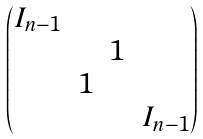<formula> <loc_0><loc_0><loc_500><loc_500>\begin{pmatrix} I _ { n - 1 } & & & \\ & & 1 & \\ & 1 & & \\ & & & I _ { n - 1 } \end{pmatrix}</formula> 